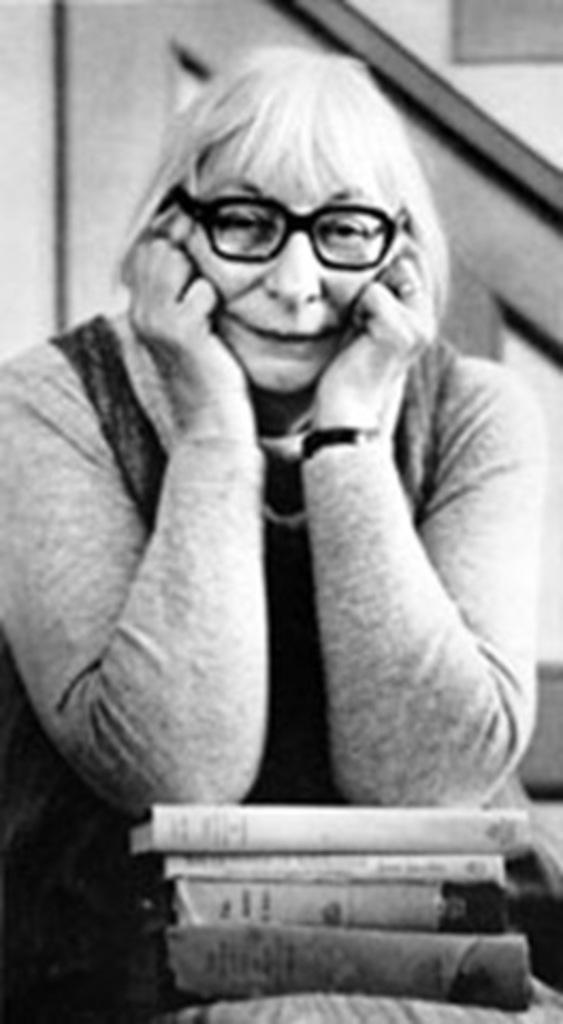What is the color scheme of the image? The image is black and white. Who is present in the image? There is a woman in the image. What objects can be seen near the woman? There are books in front of the woman. What type of waste can be seen in the image? There is no waste present in the image. What color is the woman's lipstick in the image? The image is black and white, so it is not possible to determine the color of the woman's lipstick. 